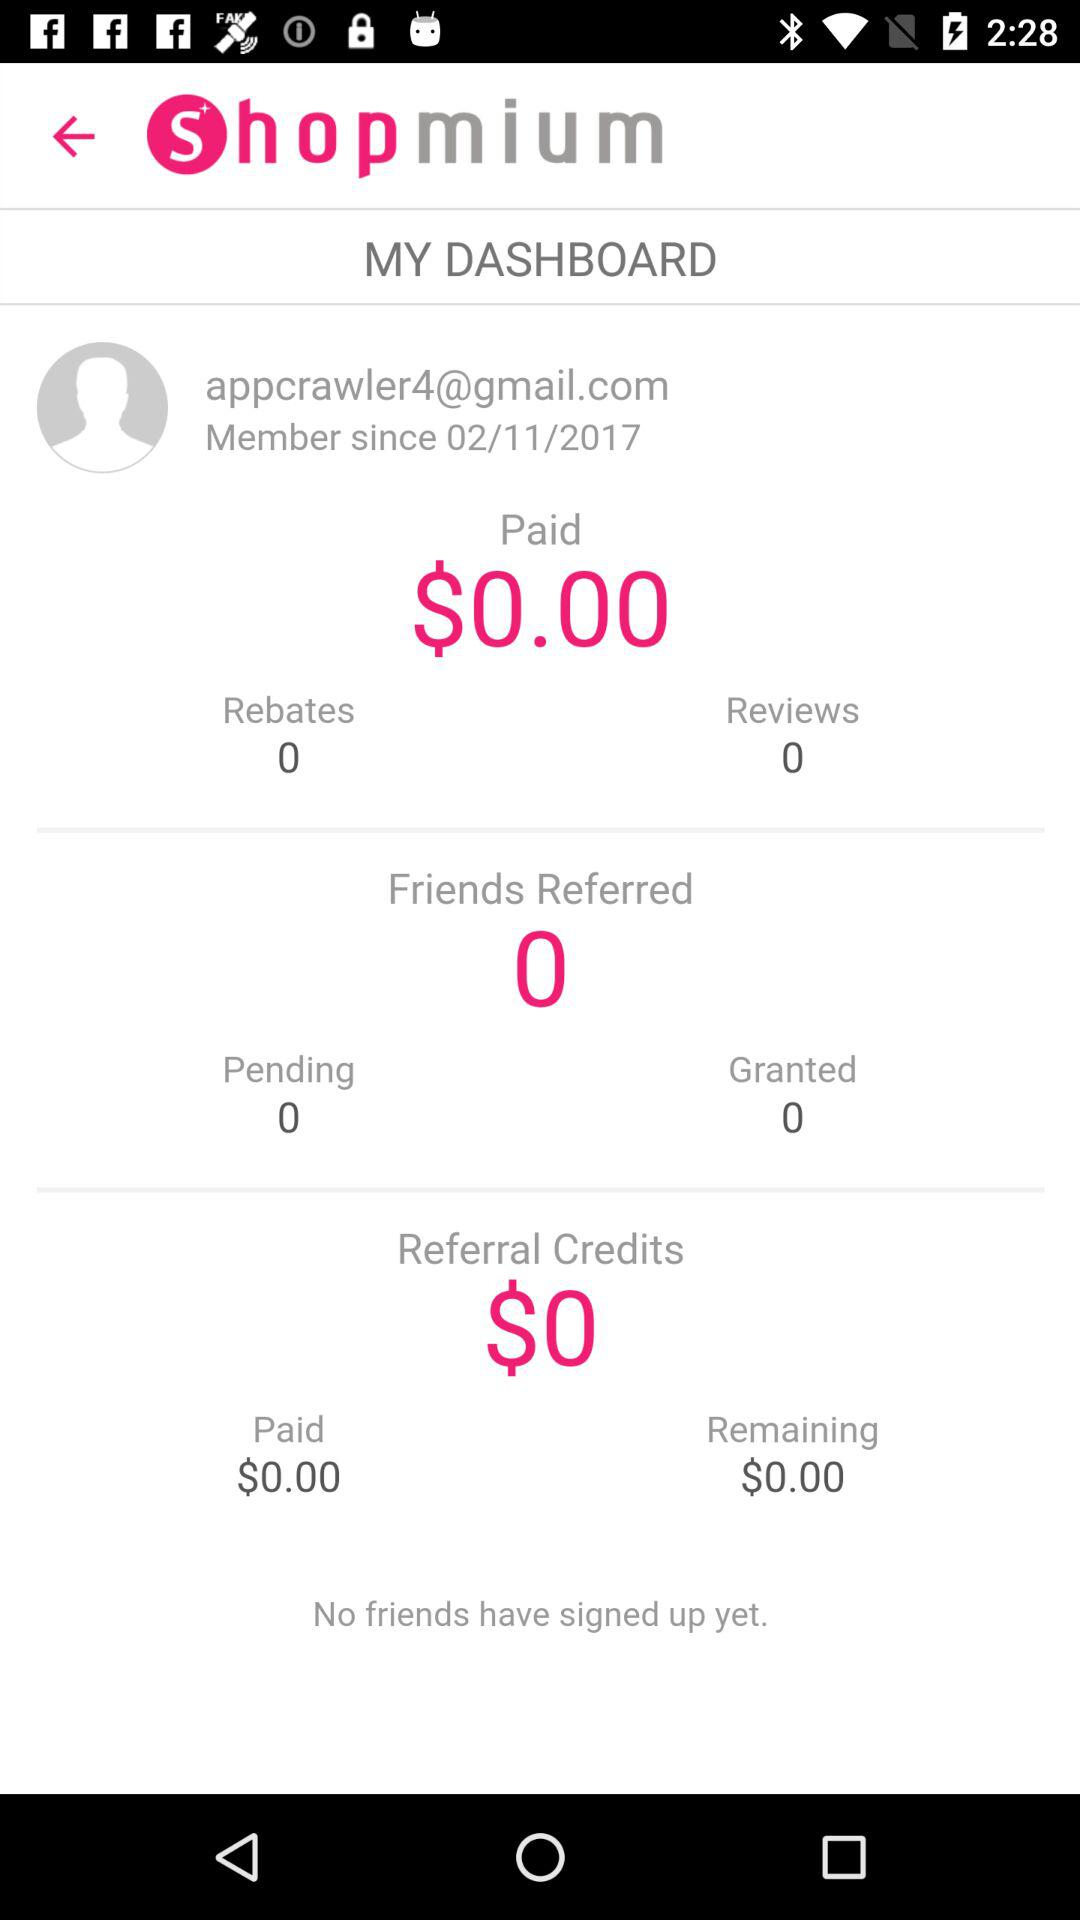How long have I been a member of the app? You have been a member of the app since November 2, 2017. 